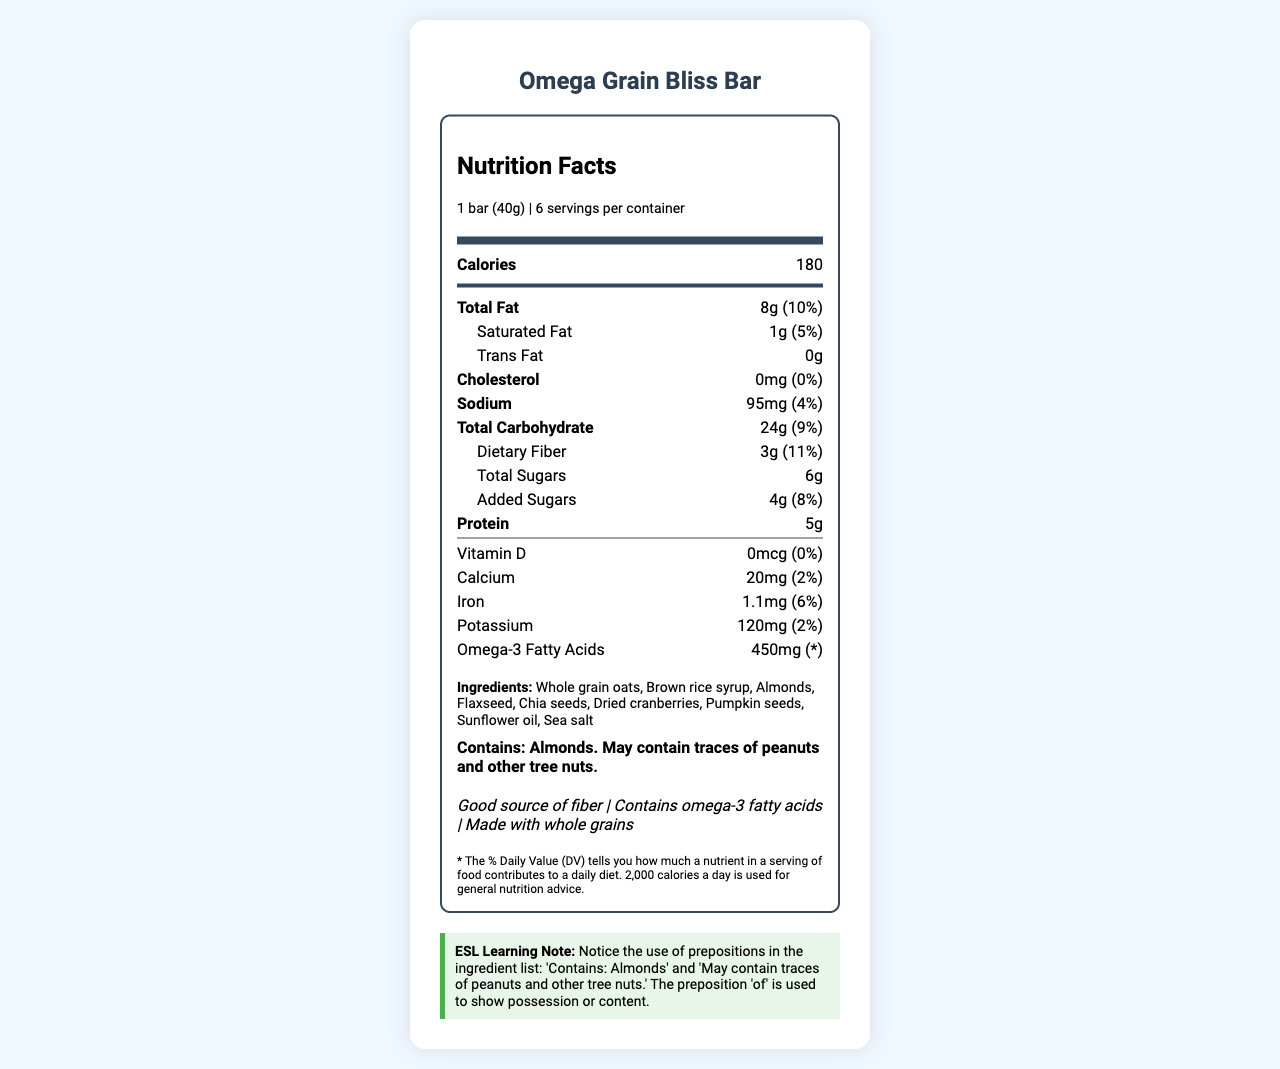what is the serving size for the Omega Grain Bliss Bar? The serving size is specified at the beginning of the nutrition label: "1 bar (40g)".
Answer: 1 bar (40g) how many servings are there per container? This is found right next to the serving size under the nutrition header: "6 servings per container".
Answer: 6 how many calories are in one serving? The calorie count is displayed prominently in the nutrition label: "Calories 180".
Answer: 180 what percentage of the daily value of fiber is in one bar? The daily value percentage for dietary fiber is listed under the total carbohydrate section: "Dietary Fiber 3g (11%)".
Answer: 11% which ingredient in the bar provides omega-3 fatty acids? Among the ingredients listed, flaxseed and chia seeds are known sources of omega-3 fatty acids.
Answer: Flaxseed and Chia seeds which of the following statements is true? A. The bar contains trans fat B. The bar contains cholesterol C. The bar has added sugars D. The bar contains vitamin D The bar contains added sugars, as indicated: "Added Sugars 4g (8%)". There is 0g trans fat, 0mg cholesterol, and 0mcg vitamin D.
Answer: C how much total fat is in one serving of the bar? A. 5g B. 1g C. 10g D. 8g The nutrition label shows: "Total Fat 8g (10%)".
Answer: D does the bar contain calcium? According to the nutrition label, the bar contains 20mg of calcium.
Answer: Yes summarize the main nutritional benefits of the Omega Grain Bliss Bar. The summary includes the key nutritional highlights from the label, focusing on the health claims, essential nutrients, and low levels of undesirable components.
Answer: The Omega Grain Bliss Bar is a nutritious snack that provides good sources of fiber and omega-3 fatty acids. It contains whole grain ingredients and has moderate amounts of calories, total fat, and carbohydrates per serving. It is low in cholesterol and trans fat. how much protein does the bar have? The nutrition label specifies: "Protein 5g".
Answer: 5g what are the main ingredients of the bar? The main ingredients are listed under the ingredients section of the label.
Answer: Whole grain oats, Brown rice syrup, Almonds, Flaxseed, Chia seeds, Dried cranberries, Pumpkin seeds, Sunflower oil, Sea salt how much omega-3 fatty acid does one serving contain? The nutrition label lists the amount of omega-3 fatty acids under the specific nutrients section: "Omega-3 Fatty Acids 450mg".
Answer: 450mg is the serving size of the Omega Grain Bliss Bar appropriate for all age groups? The document does not provide enough details to determine if the serving size is appropriate for different age groups.
Answer: Not enough information how much potassium is in one bar? The nutrition label specifies: "Potassium 120mg (2%)".
Answer: 120mg what allergens are present in the Omega Grain Bliss Bar? The allergen information section states: "Contains: Almonds. May contain traces of peanuts and other tree nuts".
Answer: Almonds; may contain traces of peanuts and other tree nuts 